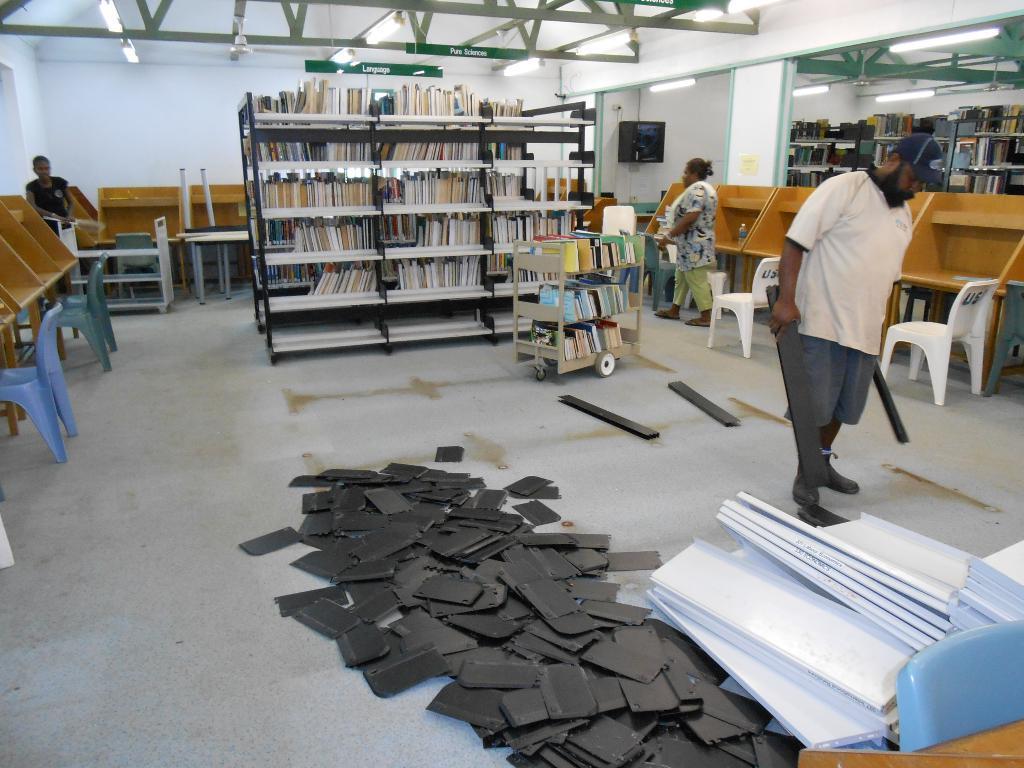How would you summarize this image in a sentence or two? As we can see in the image there are three people standing on floor. In the middle there is a rack and the rack is filled with books. On right side there is a mirror and there is a white color wall over here. 